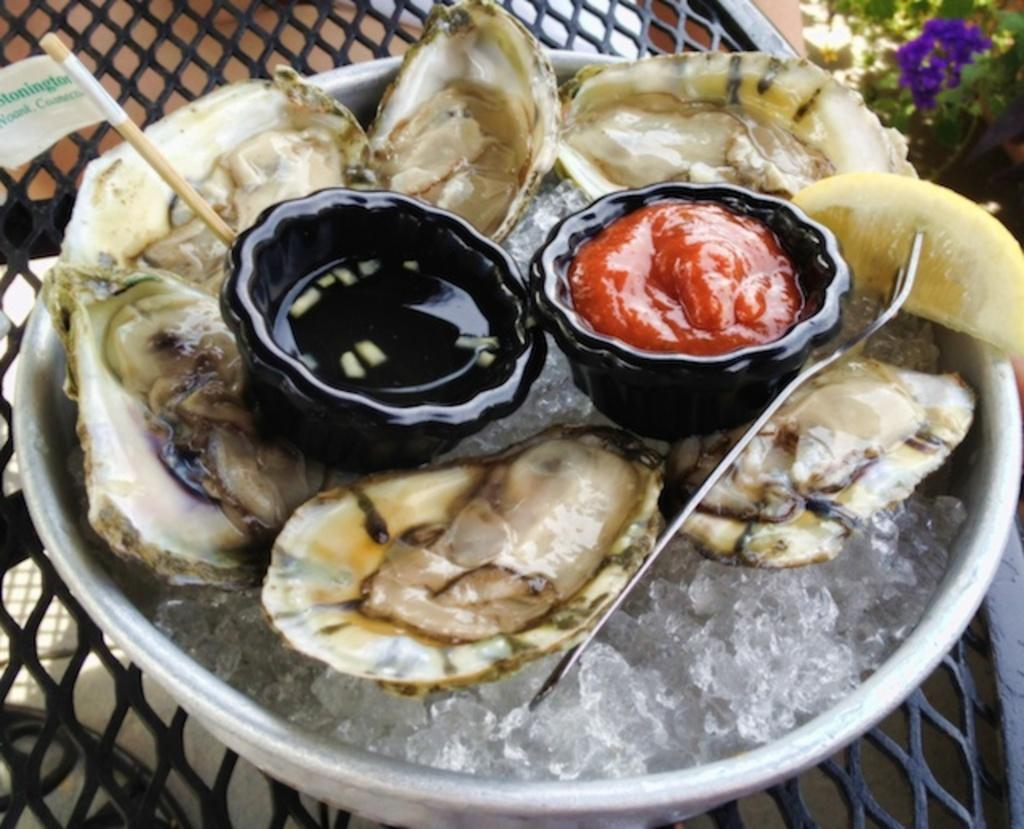What type of food item is present in the image? There is a food item in the image, but the specific type is not mentioned in the facts. What color are the bowls containing the food item? The bowls are black in color. How are the bowls arranged in the image? The bowls are on a plate. Where is the plate located in the image? The plate is in the middle of the image. What year is depicted in the image? The facts provided do not mention any specific year or time period, so it is not possible to determine the year depicted in the image. 